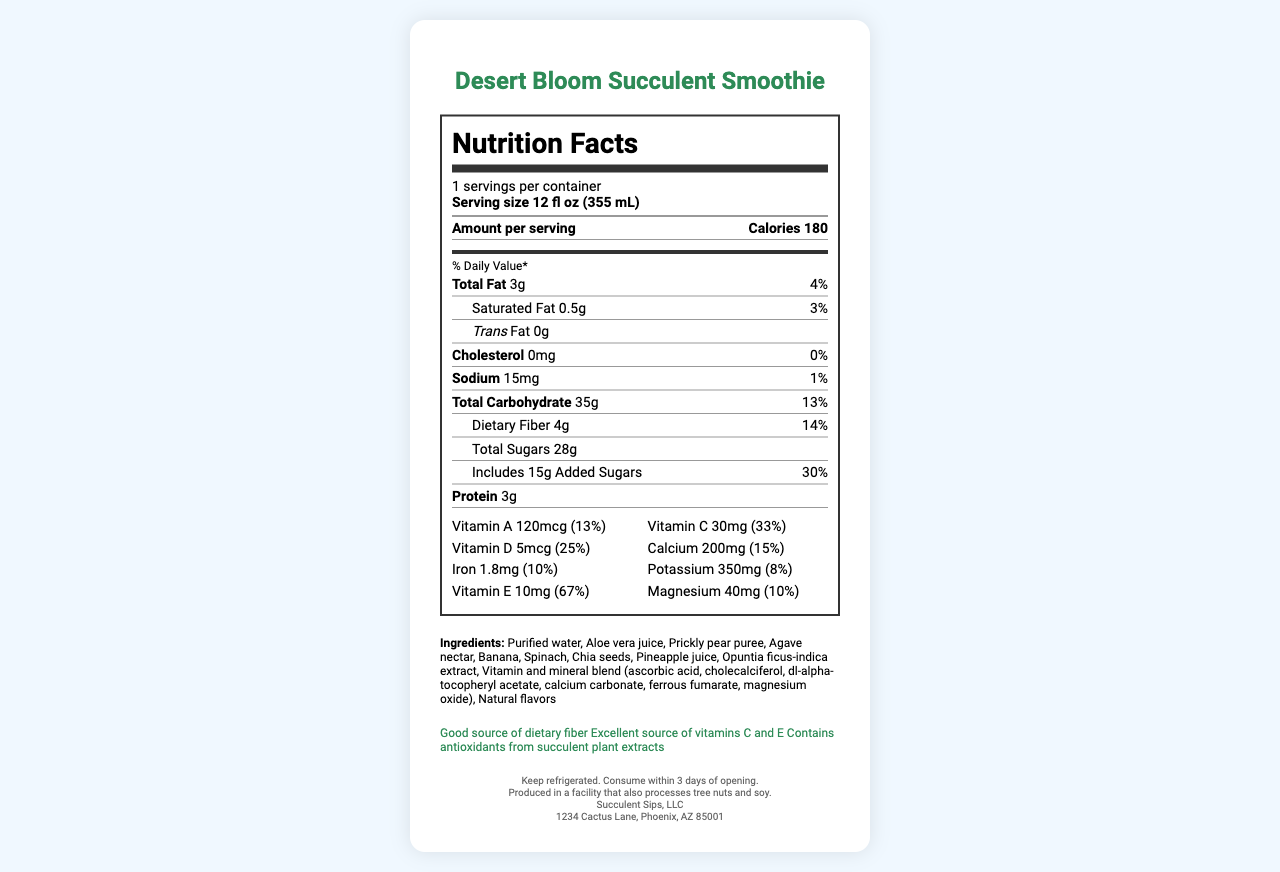what is the serving size of the Desert Bloom Succulent Smoothie? The serving size is mentioned under the serving information section as "Serving size 12 fl oz (355 mL)".
Answer: 12 fl oz (355 mL) how much dietary fiber is in one serving? Under the nutrient section, it shows "Dietary Fiber 4g".
Answer: 4g what percentage of daily calcium is provided per serving? The vitamin section displays "Calcium 200mg (15%)".
Answer: 15% is there any cholesterol in this smoothie? The nutrient section lists "Cholesterol 0mg" with a daily value of "0%".
Answer: No what are the first three ingredients listed? The ingredients are listed under the ingredients section, and the first three are "Purified water, Aloe vera juice, Prickly pear puree".
Answer: Purified water, Aloe vera juice, Prickly pear puree how many grams of protein are in the smoothie? The amount of protein is provided in the nutrient section as "Protein 3g".
Answer: 3g what is the total carbohydrate content per serving? A. 30g B. 35g C. 40g D. 45g The total carbohydrate amount is listed as "35g" in the nutrient section.
Answer: B. 35g which vitamin provides the highest percentage of daily value? A. Vitamin A B. Vitamin C C. Vitamin D D. Vitamin E The vitamin section shows Vitamin E providing "67%" daily value, which is the highest among all listed vitamins.
Answer: D. Vitamin E is this product a good source of dietary fiber? The health claims section states "Good source of dietary fiber".
Answer: Yes what is the storage instruction for this product? The storage instructions section explicitly mentions "Keep refrigerated. Consume within 3 days of opening".
Answer: Keep refrigerated. Consume within 3 days of opening. which of the following statements about the smoothie is true? A. It contains tree nuts B. It contains artificial flavors C. It is produced in a facility that processes tree nuts and soy D. It has no added sugars The allergen info section states, "Produced in a facility that also processes tree nuts and soy".
Answer: C. It is produced in a facility that processes tree nuts and soy summarize the main idea of this nutrition label This answer includes various details found throughout the document, which collectively describe the Desert Bloom Succulent Smoothie.
Answer: This document provides detailed nutritional information for the "Desert Bloom Succulent Smoothie," including serving size, calorie count, fat content, carbohydrate content, and vitamins. It lists ingredients, allergen information, health claims, and storage instructions. does this product contain any soy ingredients? The label states that it is produced in a facility that processes soy, but it does not explicitly state whether soy is an ingredient in the smoothie.
Answer: Cannot be determined 